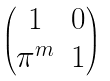Convert formula to latex. <formula><loc_0><loc_0><loc_500><loc_500>\begin{pmatrix} 1 & 0 \\ \pi ^ { m } & 1 \end{pmatrix}</formula> 